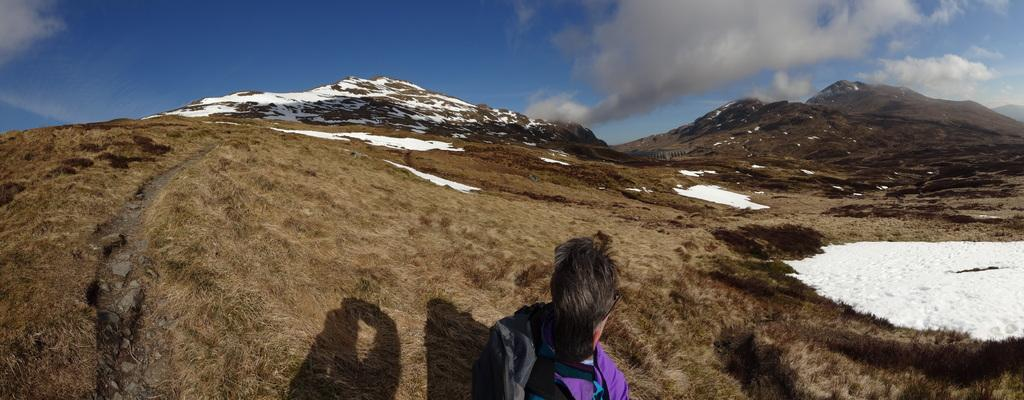Who or what is at the bottom of the image? There is a person at the bottom of the image. What is the person's location in relation to the other elements in the image? The person is at the bottom of the image. What type of natural landscape can be seen in the image? There are mountains visible in the image, and there is snow present. What is the condition of the sky in the image? Clouds are present in the sky in the image. What type of humor can be seen in the image? There is no humor present in the image; it features a person in a snowy mountainous landscape with clouds in the sky. Is there a fan visible in the image? There is no fan present in the image. 